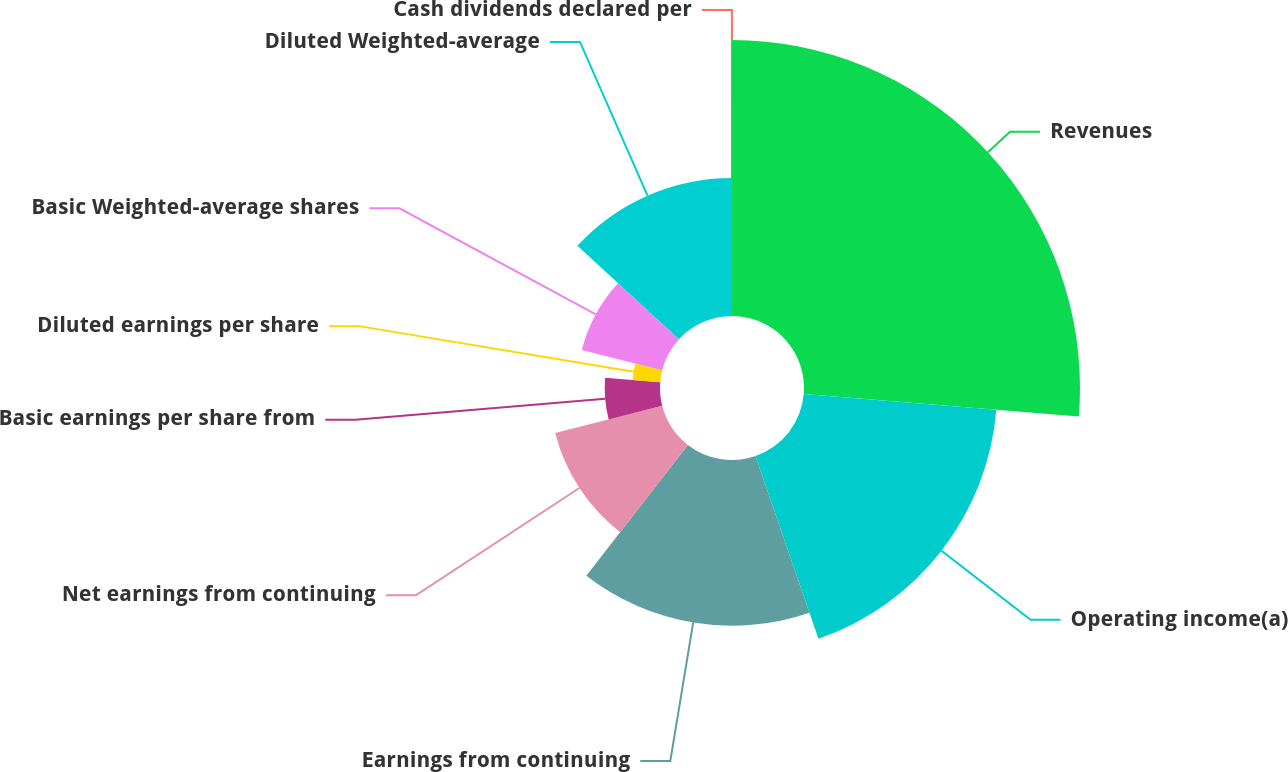<chart> <loc_0><loc_0><loc_500><loc_500><pie_chart><fcel>Revenues<fcel>Operating income(a)<fcel>Earnings from continuing<fcel>Net earnings from continuing<fcel>Basic earnings per share from<fcel>Diluted earnings per share<fcel>Basic Weighted-average shares<fcel>Diluted Weighted-average<fcel>Cash dividends declared per<nl><fcel>26.31%<fcel>18.42%<fcel>15.79%<fcel>10.53%<fcel>5.27%<fcel>2.64%<fcel>7.9%<fcel>13.16%<fcel>0.01%<nl></chart> 